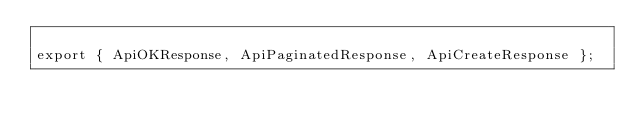Convert code to text. <code><loc_0><loc_0><loc_500><loc_500><_TypeScript_>
export { ApiOKResponse, ApiPaginatedResponse, ApiCreateResponse };
</code> 